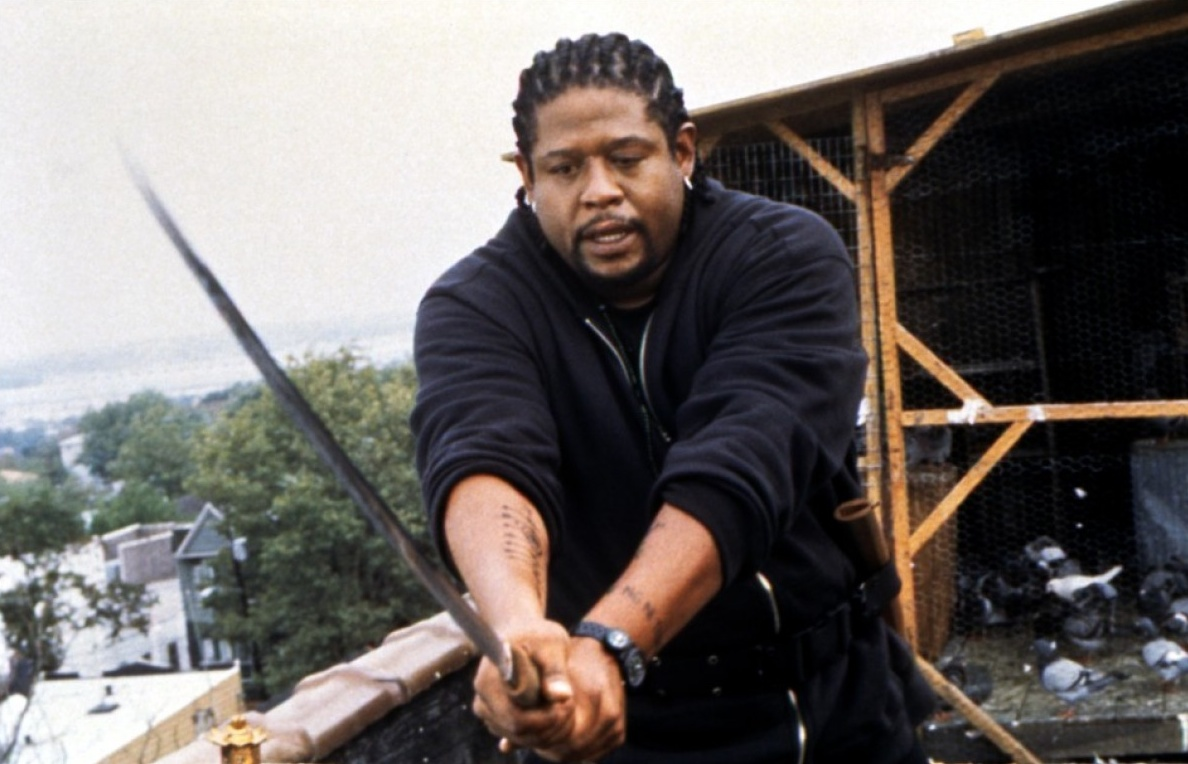If this scene were part of a broader story, what themes would it explore? If this scene were part of a broader story, it would likely explore themes such as honor, vengeance, and the delicate balance between violence and peace. The character's determined and intense demeanor suggests a personal mission or code they are fiercely upholding. The urban setting, juxtaposed with the wooden pigeon coop, could symbolize the encroachment of chaos into everyday life. Themes of survival and the constant battle between one's inner demons and external threats might also be present, creating a narrative rich with tension and moral complexity, compelling the audience to reflect on the struggles faced by the characters. 